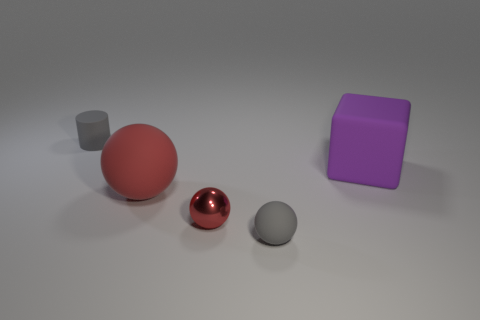What size is the object that is the same color as the shiny ball?
Your response must be concise. Large. Is there any other thing that is the same material as the small red sphere?
Provide a succinct answer. No. What number of other objects are the same color as the big matte ball?
Offer a terse response. 1. Do the cylinder and the tiny matte object in front of the purple matte thing have the same color?
Ensure brevity in your answer.  Yes. There is a thing that is both left of the small red metal thing and in front of the matte cylinder; what is its material?
Ensure brevity in your answer.  Rubber. There is a small gray object that is behind the gray thing that is in front of the tiny metal object; is there a gray rubber thing in front of it?
Give a very brief answer. Yes. What size is the gray thing on the right side of the large ball?
Provide a short and direct response. Small. What material is the red sphere that is the same size as the gray rubber cylinder?
Give a very brief answer. Metal. Is the shape of the metal object the same as the large red rubber thing?
Your answer should be very brief. Yes. What number of things are small cyan metal cylinders or tiny things in front of the cylinder?
Offer a terse response. 2. 